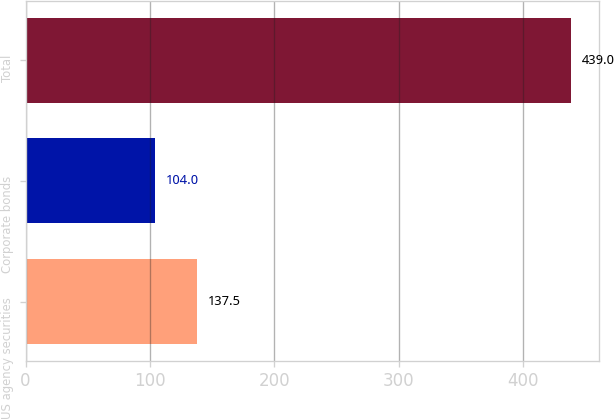Convert chart. <chart><loc_0><loc_0><loc_500><loc_500><bar_chart><fcel>US agency securities<fcel>Corporate bonds<fcel>Total<nl><fcel>137.5<fcel>104<fcel>439<nl></chart> 